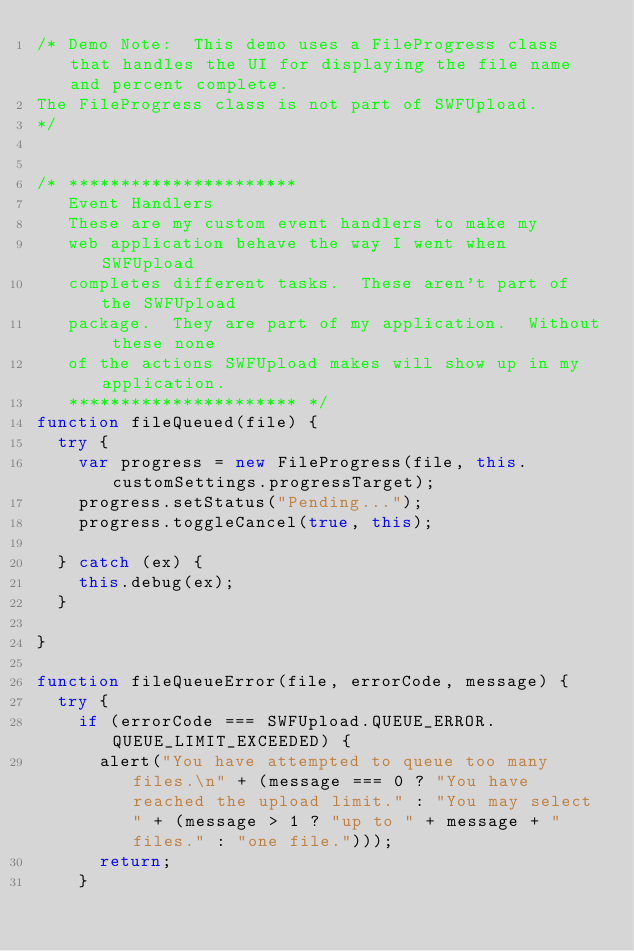<code> <loc_0><loc_0><loc_500><loc_500><_JavaScript_>/* Demo Note:  This demo uses a FileProgress class that handles the UI for displaying the file name and percent complete.
The FileProgress class is not part of SWFUpload.
*/


/* **********************
   Event Handlers
   These are my custom event handlers to make my
   web application behave the way I went when SWFUpload
   completes different tasks.  These aren't part of the SWFUpload
   package.  They are part of my application.  Without these none
   of the actions SWFUpload makes will show up in my application.
   ********************** */
function fileQueued(file) {
  try {
    var progress = new FileProgress(file, this.customSettings.progressTarget);
    progress.setStatus("Pending...");
    progress.toggleCancel(true, this);

  } catch (ex) {
    this.debug(ex);
  }

}

function fileQueueError(file, errorCode, message) {
  try {
    if (errorCode === SWFUpload.QUEUE_ERROR.QUEUE_LIMIT_EXCEEDED) {
      alert("You have attempted to queue too many files.\n" + (message === 0 ? "You have reached the upload limit." : "You may select " + (message > 1 ? "up to " + message + " files." : "one file.")));
      return;
    }
</code> 